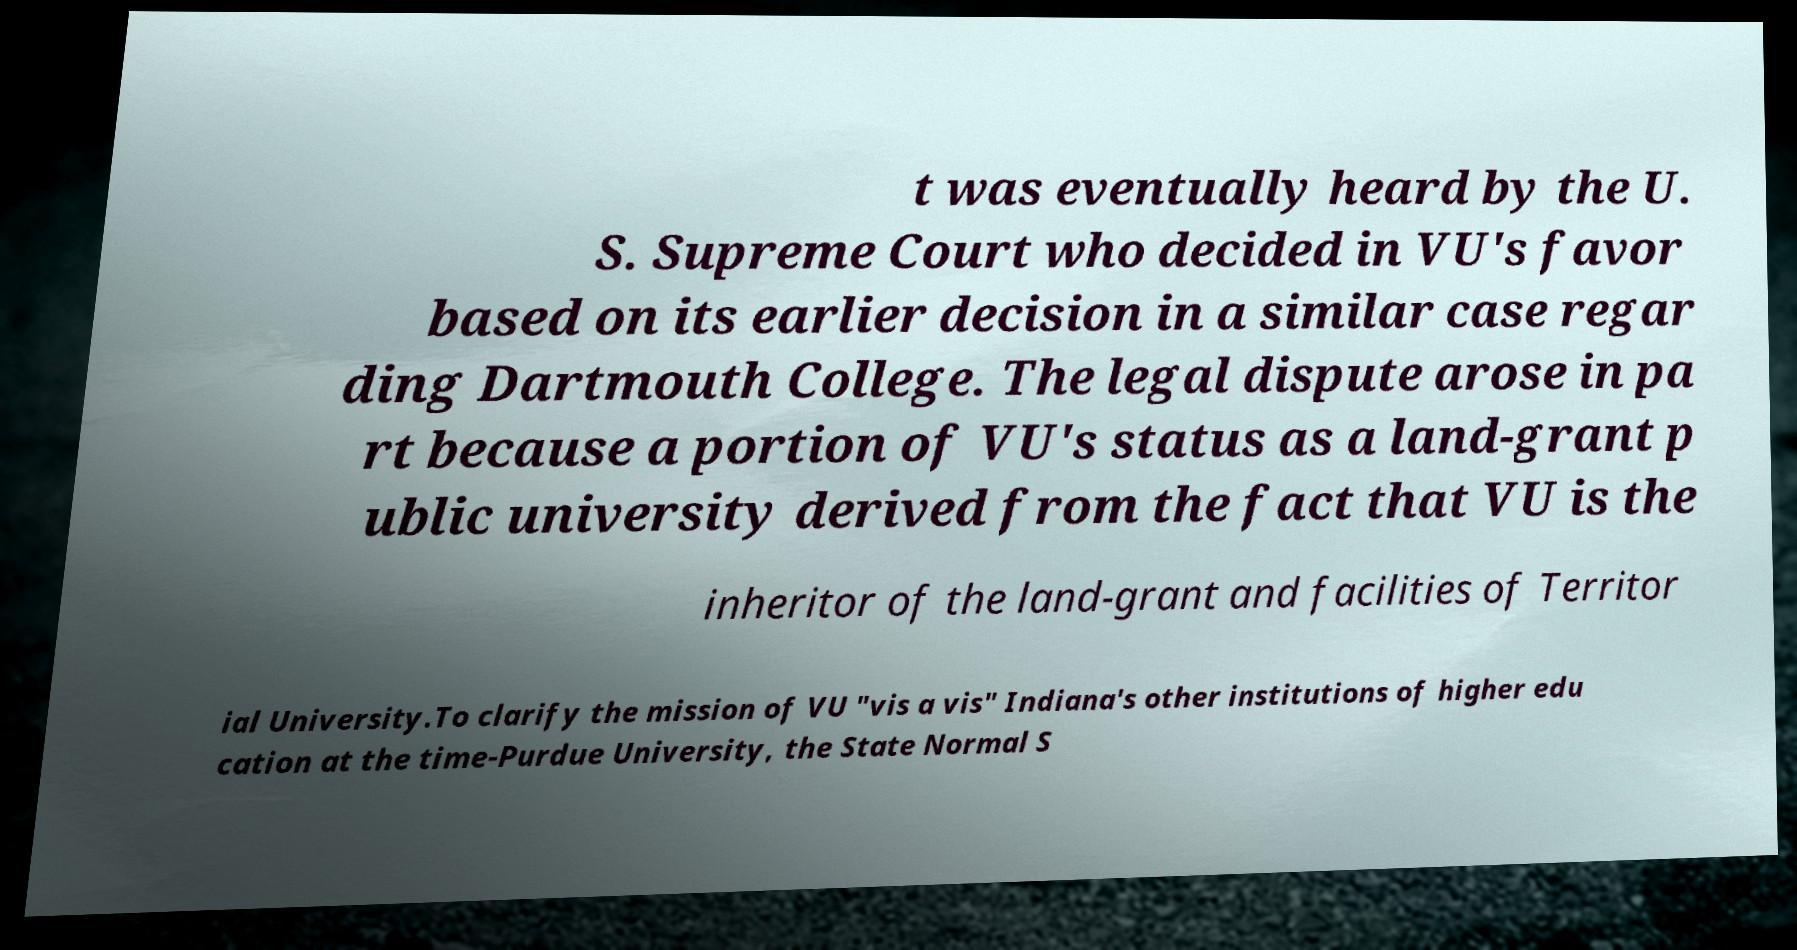Could you assist in decoding the text presented in this image and type it out clearly? t was eventually heard by the U. S. Supreme Court who decided in VU's favor based on its earlier decision in a similar case regar ding Dartmouth College. The legal dispute arose in pa rt because a portion of VU's status as a land-grant p ublic university derived from the fact that VU is the inheritor of the land-grant and facilities of Territor ial University.To clarify the mission of VU "vis a vis" Indiana's other institutions of higher edu cation at the time-Purdue University, the State Normal S 